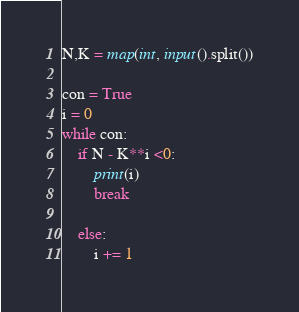Convert code to text. <code><loc_0><loc_0><loc_500><loc_500><_Python_>N,K = map(int, input().split())

con = True
i = 0
while con:
    if N - K**i <0:
        print(i)
        break

    else:
        i += 1
</code> 